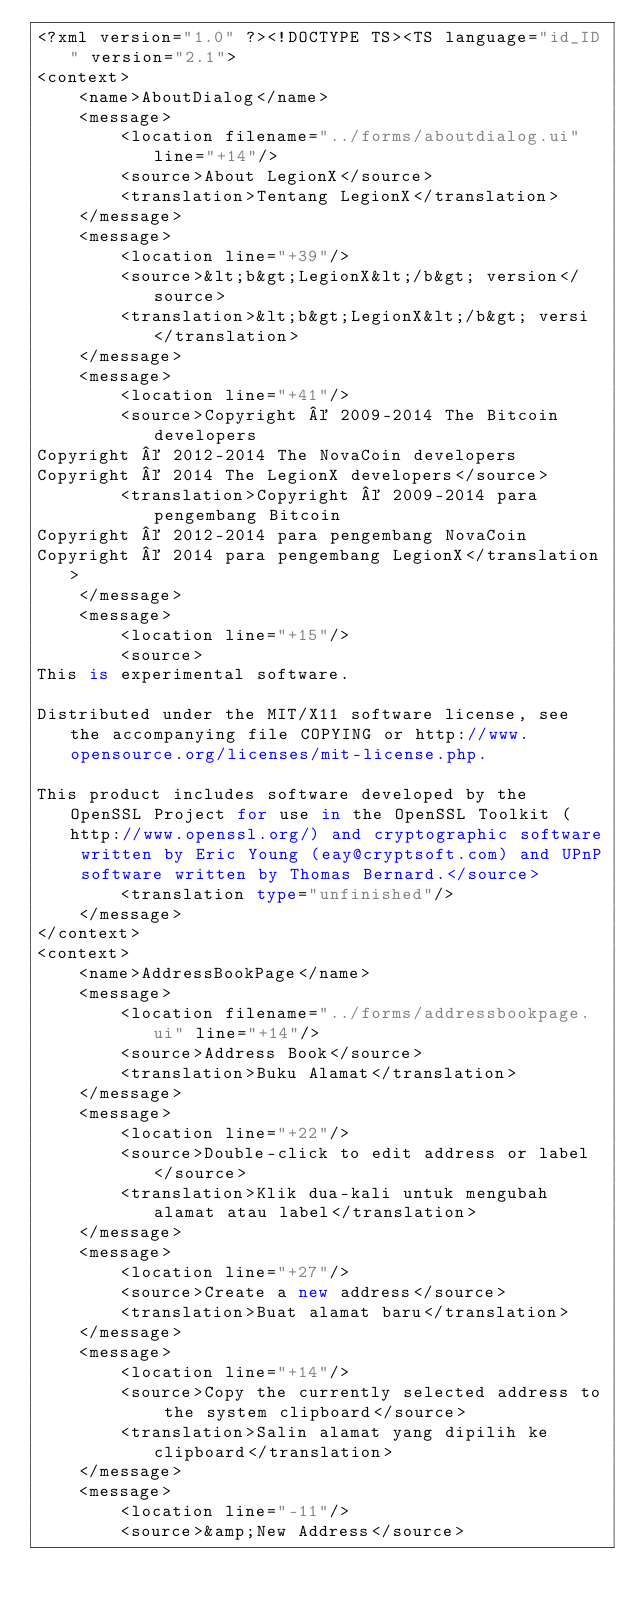Convert code to text. <code><loc_0><loc_0><loc_500><loc_500><_TypeScript_><?xml version="1.0" ?><!DOCTYPE TS><TS language="id_ID" version="2.1">
<context>
    <name>AboutDialog</name>
    <message>
        <location filename="../forms/aboutdialog.ui" line="+14"/>
        <source>About LegionX</source>
        <translation>Tentang LegionX</translation>
    </message>
    <message>
        <location line="+39"/>
        <source>&lt;b&gt;LegionX&lt;/b&gt; version</source>
        <translation>&lt;b&gt;LegionX&lt;/b&gt; versi</translation>
    </message>
    <message>
        <location line="+41"/>
        <source>Copyright © 2009-2014 The Bitcoin developers
Copyright © 2012-2014 The NovaCoin developers
Copyright © 2014 The LegionX developers</source>
        <translation>Copyright © 2009-2014 para pengembang Bitcoin
Copyright © 2012-2014 para pengembang NovaCoin
Copyright © 2014 para pengembang LegionX</translation>
    </message>
    <message>
        <location line="+15"/>
        <source>
This is experimental software.

Distributed under the MIT/X11 software license, see the accompanying file COPYING or http://www.opensource.org/licenses/mit-license.php.

This product includes software developed by the OpenSSL Project for use in the OpenSSL Toolkit (http://www.openssl.org/) and cryptographic software written by Eric Young (eay@cryptsoft.com) and UPnP software written by Thomas Bernard.</source>
        <translation type="unfinished"/>
    </message>
</context>
<context>
    <name>AddressBookPage</name>
    <message>
        <location filename="../forms/addressbookpage.ui" line="+14"/>
        <source>Address Book</source>
        <translation>Buku Alamat</translation>
    </message>
    <message>
        <location line="+22"/>
        <source>Double-click to edit address or label</source>
        <translation>Klik dua-kali untuk mengubah alamat atau label</translation>
    </message>
    <message>
        <location line="+27"/>
        <source>Create a new address</source>
        <translation>Buat alamat baru</translation>
    </message>
    <message>
        <location line="+14"/>
        <source>Copy the currently selected address to the system clipboard</source>
        <translation>Salin alamat yang dipilih ke clipboard</translation>
    </message>
    <message>
        <location line="-11"/>
        <source>&amp;New Address</source></code> 